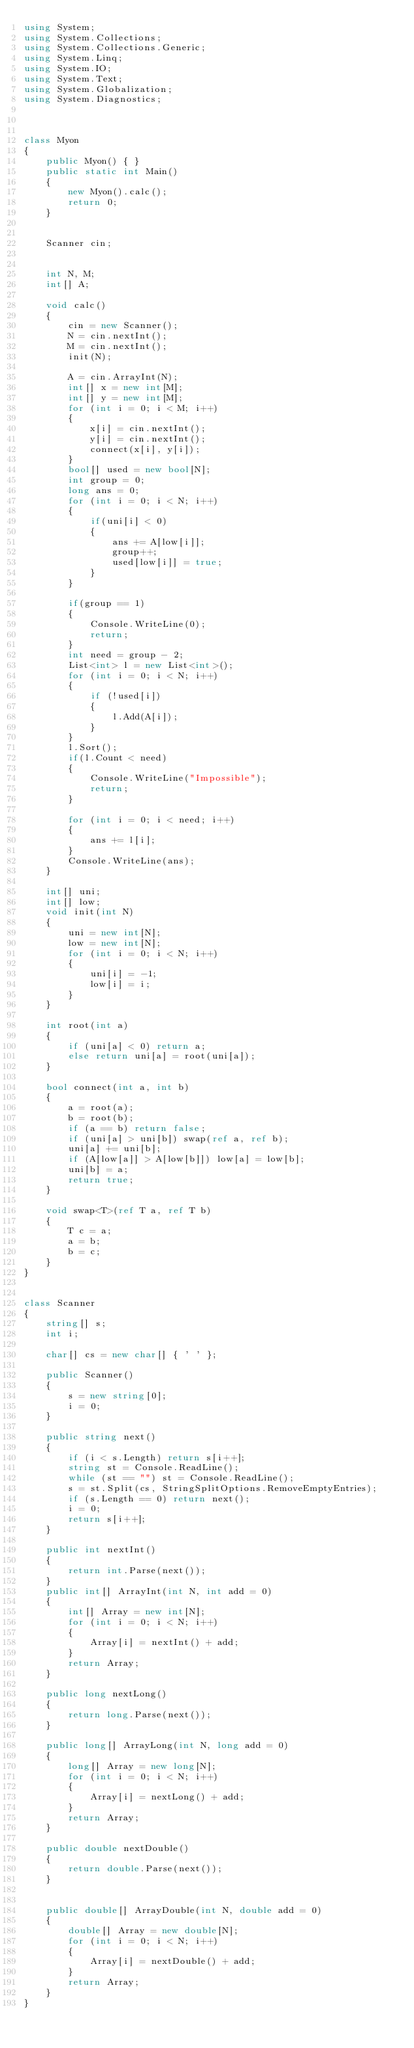<code> <loc_0><loc_0><loc_500><loc_500><_C#_>using System;
using System.Collections;
using System.Collections.Generic;
using System.Linq;
using System.IO;
using System.Text;
using System.Globalization;
using System.Diagnostics;



class Myon
{
    public Myon() { }
    public static int Main()
    {
        new Myon().calc();
        return 0;
    }


    Scanner cin;


    int N, M;
    int[] A;

    void calc()
    {
        cin = new Scanner();
        N = cin.nextInt();
        M = cin.nextInt();
        init(N);

        A = cin.ArrayInt(N);
        int[] x = new int[M];
        int[] y = new int[M];
        for (int i = 0; i < M; i++)
        {
            x[i] = cin.nextInt();
            y[i] = cin.nextInt();
            connect(x[i], y[i]);
        }
        bool[] used = new bool[N];
        int group = 0;
        long ans = 0;
        for (int i = 0; i < N; i++)
        {
            if(uni[i] < 0)
            {
                ans += A[low[i]];
                group++;
                used[low[i]] = true;
            }
        }
        
        if(group == 1)
        {
            Console.WriteLine(0);
            return;
        }
        int need = group - 2;
        List<int> l = new List<int>();
        for (int i = 0; i < N; i++)
        {
            if (!used[i])
            {
                l.Add(A[i]);
            }
        }
        l.Sort();
        if(l.Count < need)
        {
            Console.WriteLine("Impossible");
            return;
        }

        for (int i = 0; i < need; i++)
        {
            ans += l[i];
        }
        Console.WriteLine(ans);
    }

    int[] uni;
    int[] low;
    void init(int N)
    {
        uni = new int[N];
        low = new int[N];
        for (int i = 0; i < N; i++)
        {
            uni[i] = -1;
            low[i] = i;
        }
    }

    int root(int a)
    {
        if (uni[a] < 0) return a;
        else return uni[a] = root(uni[a]);
    }

    bool connect(int a, int b)
    {
        a = root(a);
        b = root(b);
        if (a == b) return false;
        if (uni[a] > uni[b]) swap(ref a, ref b);
        uni[a] += uni[b];
        if (A[low[a]] > A[low[b]]) low[a] = low[b];
        uni[b] = a;
        return true;
    }

    void swap<T>(ref T a, ref T b)
    {
        T c = a;
        a = b;
        b = c;
    }  
}


class Scanner
{
    string[] s;
    int i;

    char[] cs = new char[] { ' ' };

    public Scanner()
    {
        s = new string[0];
        i = 0;
    }

    public string next()
    {
        if (i < s.Length) return s[i++];
        string st = Console.ReadLine();
        while (st == "") st = Console.ReadLine();
        s = st.Split(cs, StringSplitOptions.RemoveEmptyEntries);
        if (s.Length == 0) return next();
        i = 0;
        return s[i++];
    }

    public int nextInt()
    {
        return int.Parse(next());
    }
    public int[] ArrayInt(int N, int add = 0)
    {
        int[] Array = new int[N];
        for (int i = 0; i < N; i++)
        {
            Array[i] = nextInt() + add;
        }
        return Array;
    }

    public long nextLong()
    {
        return long.Parse(next());
    }

    public long[] ArrayLong(int N, long add = 0)
    {
        long[] Array = new long[N];
        for (int i = 0; i < N; i++)
        {
            Array[i] = nextLong() + add;
        }
        return Array;
    }

    public double nextDouble()
    {
        return double.Parse(next());
    }


    public double[] ArrayDouble(int N, double add = 0)
    {
        double[] Array = new double[N];
        for (int i = 0; i < N; i++)
        {
            Array[i] = nextDouble() + add;
        }
        return Array;
    }
}
</code> 